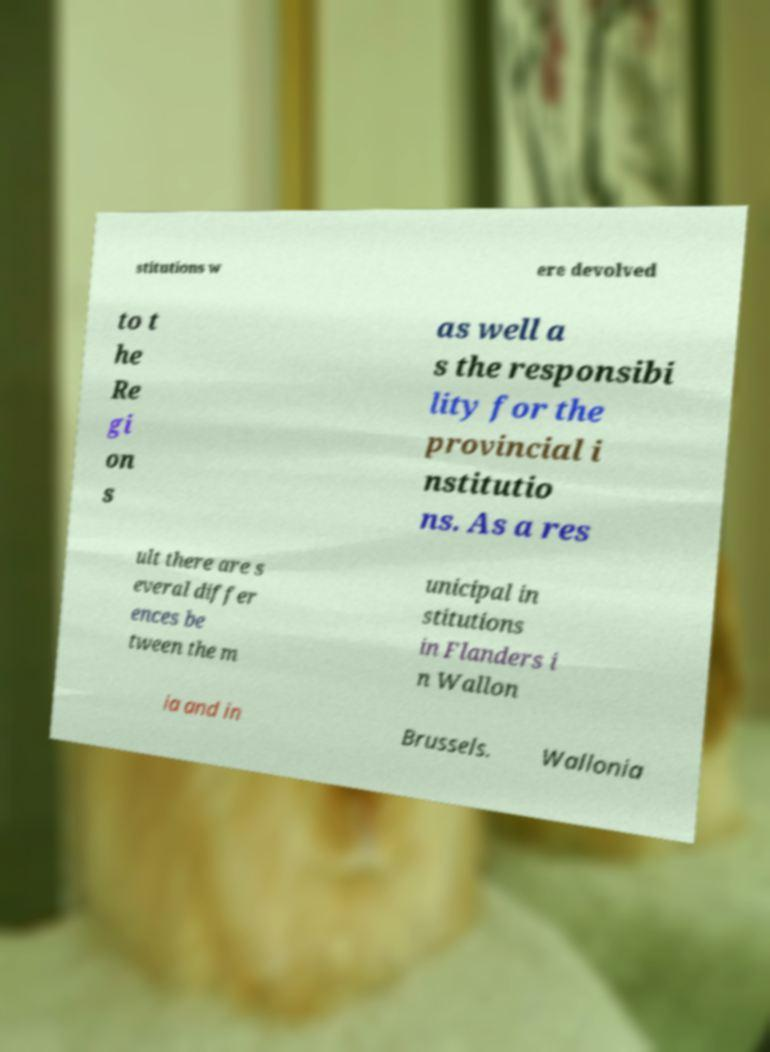I need the written content from this picture converted into text. Can you do that? stitutions w ere devolved to t he Re gi on s as well a s the responsibi lity for the provincial i nstitutio ns. As a res ult there are s everal differ ences be tween the m unicipal in stitutions in Flanders i n Wallon ia and in Brussels. Wallonia 